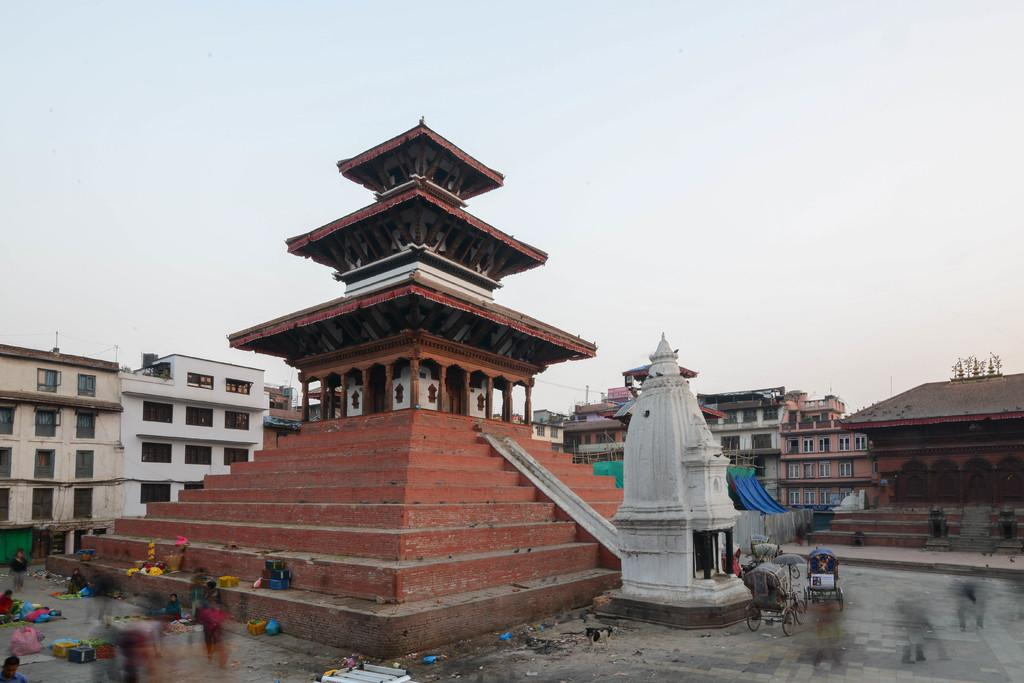What type of structure is present in the image? There are stairs and buildings in the image. Can you describe the sky in the image? The sky is visible in the image, and it is cloudy. What type of muscle is being exercised by the person walking up the stairs in the image? There is no person walking up the stairs in the image, and therefore no muscle being exercised can be observed. 